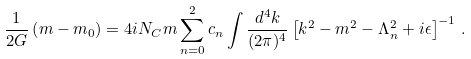Convert formula to latex. <formula><loc_0><loc_0><loc_500><loc_500>\frac { 1 } { 2 G } \left ( m - m _ { 0 } \right ) = 4 i N _ { C } m \sum _ { n = 0 } ^ { 2 } c _ { n } \int \frac { d ^ { 4 } k } { ( 2 \pi ) ^ { 4 } } \left [ k ^ { 2 } - m ^ { 2 } - \Lambda _ { n } ^ { 2 } + i \epsilon \right ] ^ { - 1 } \, .</formula> 